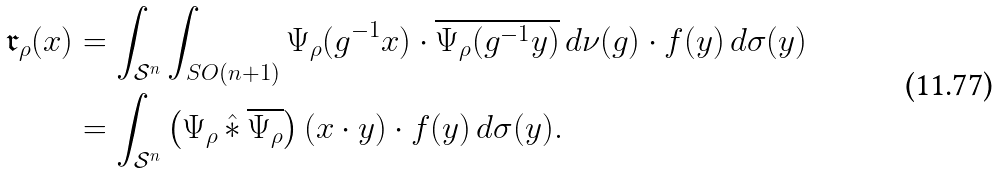Convert formula to latex. <formula><loc_0><loc_0><loc_500><loc_500>\mathfrak r _ { \rho } ( x ) & = \int _ { \mathcal { S } ^ { n } } \int _ { S O ( n + 1 ) } \Psi _ { \rho } ( g ^ { - 1 } x ) \cdot \overline { \Psi _ { \rho } ( g ^ { - 1 } y ) } \, d \nu ( g ) \cdot f ( y ) \, d \sigma ( y ) \\ & = \int _ { \mathcal { S } ^ { n } } \left ( \Psi _ { \rho } \, \hat { \ast } \, \overline { \Psi _ { \rho } } \right ) ( x \cdot y ) \cdot f ( y ) \, d \sigma ( y ) .</formula> 